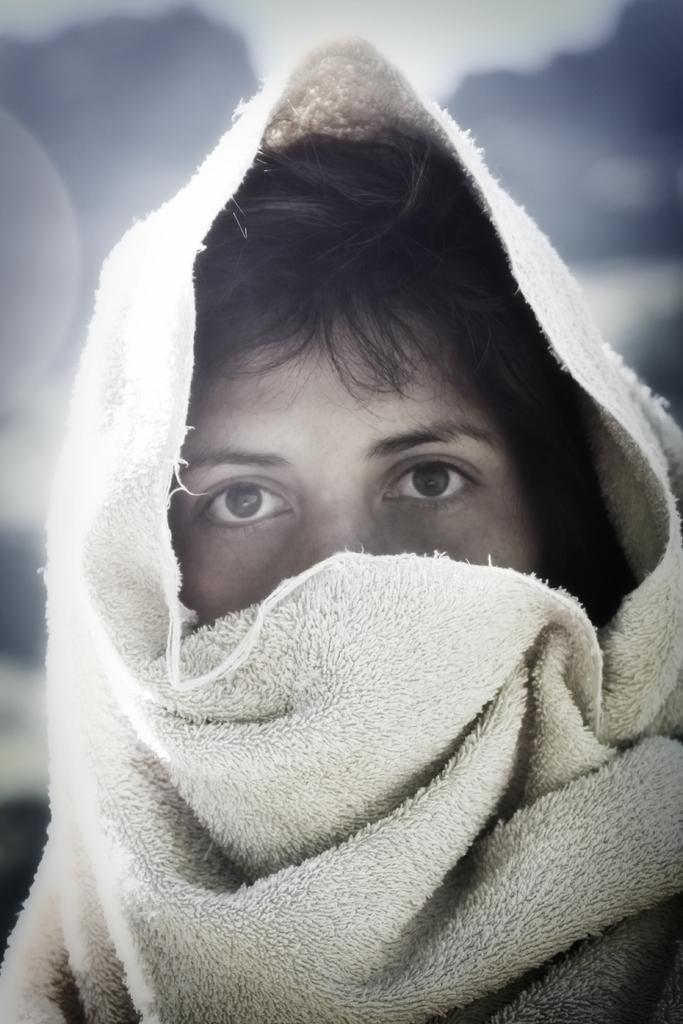Can you describe this image briefly? In this picture I can observe a person. He is wearing a cloth on his head. This cloth is in white color. The background is completely blurred. 